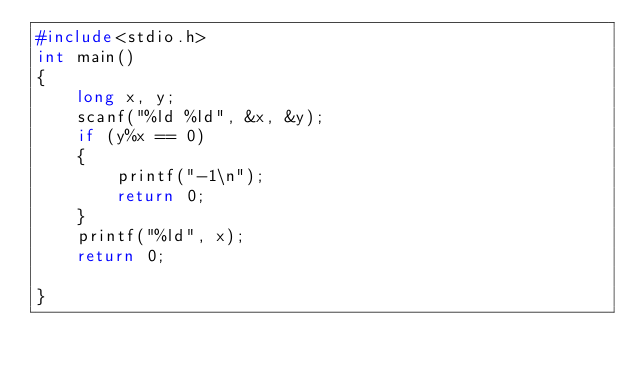Convert code to text. <code><loc_0><loc_0><loc_500><loc_500><_C++_>#include<stdio.h>
int main()
{
    long x, y;
    scanf("%ld %ld", &x, &y);
    if (y%x == 0)
    {
        printf("-1\n");
        return 0;
    }
    printf("%ld", x);
    return 0;

}</code> 